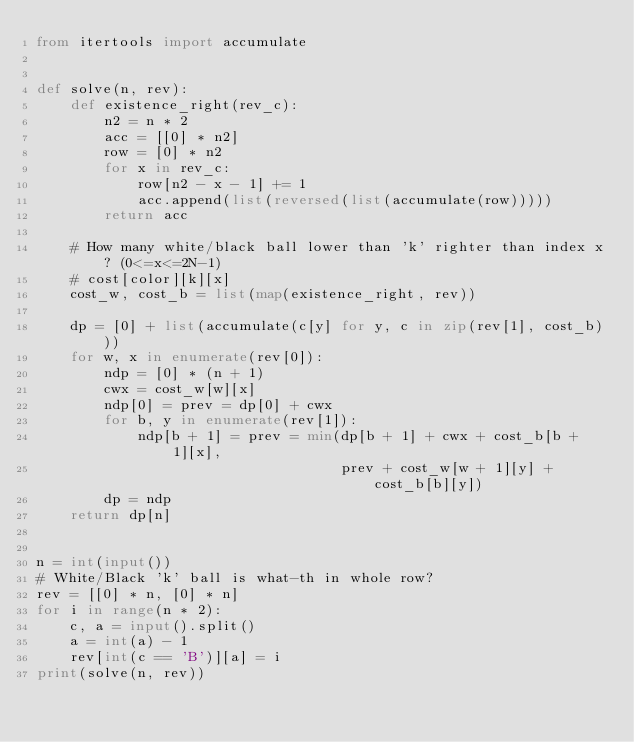Convert code to text. <code><loc_0><loc_0><loc_500><loc_500><_Python_>from itertools import accumulate


def solve(n, rev):
    def existence_right(rev_c):
        n2 = n * 2
        acc = [[0] * n2]
        row = [0] * n2
        for x in rev_c:
            row[n2 - x - 1] += 1
            acc.append(list(reversed(list(accumulate(row)))))
        return acc

    # How many white/black ball lower than 'k' righter than index x? (0<=x<=2N-1)
    # cost[color][k][x]
    cost_w, cost_b = list(map(existence_right, rev))

    dp = [0] + list(accumulate(c[y] for y, c in zip(rev[1], cost_b)))
    for w, x in enumerate(rev[0]):
        ndp = [0] * (n + 1)
        cwx = cost_w[w][x]
        ndp[0] = prev = dp[0] + cwx
        for b, y in enumerate(rev[1]):
            ndp[b + 1] = prev = min(dp[b + 1] + cwx + cost_b[b + 1][x],
                                    prev + cost_w[w + 1][y] + cost_b[b][y])
        dp = ndp
    return dp[n]


n = int(input())
# White/Black 'k' ball is what-th in whole row?
rev = [[0] * n, [0] * n]
for i in range(n * 2):
    c, a = input().split()
    a = int(a) - 1
    rev[int(c == 'B')][a] = i
print(solve(n, rev))
</code> 